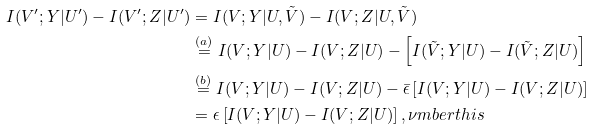<formula> <loc_0><loc_0><loc_500><loc_500>I ( V ^ { \prime } ; Y | U ^ { \prime } ) - I ( V ^ { \prime } ; Z | U ^ { \prime } ) & = I ( V ; Y | U , \tilde { V } ) - I ( V ; Z | U , \tilde { V } ) \\ & \stackrel { ( a ) } = I ( V ; Y | U ) - I ( V ; Z | U ) - \left [ I ( \tilde { V } ; Y | U ) - I ( \tilde { V } ; Z | U ) \right ] \\ & \stackrel { ( b ) } = I ( V ; Y | U ) - I ( V ; Z | U ) - \bar { \epsilon } \left [ I ( V ; Y | U ) - I ( V ; Z | U ) \right ] \\ & = \epsilon \left [ I ( V ; Y | U ) - I ( V ; Z | U ) \right ] , \nu m b e r t h i s</formula> 